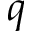<formula> <loc_0><loc_0><loc_500><loc_500>q</formula> 